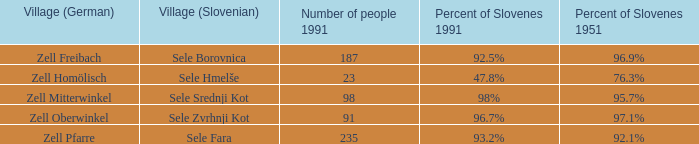Provide with the names of the village (German) that is part of village (Slovenian) with sele srednji kot. Zell Mitterwinkel. 